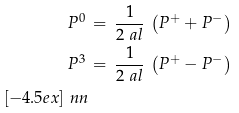<formula> <loc_0><loc_0><loc_500><loc_500>P ^ { 0 } \, & = \, \frac { 1 } { 2 \ a l } \, \left ( P ^ { + } + P ^ { - } \right ) \\ P ^ { 3 } \, & = \, \frac { 1 } { 2 \ a l } \, \left ( P ^ { + } - P ^ { - } \right ) \\ [ - 4 . 5 e x ] \ n n</formula> 